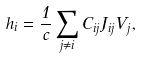Convert formula to latex. <formula><loc_0><loc_0><loc_500><loc_500>h _ { i } = \frac { 1 } { c } \sum _ { j \neq i } C _ { i j } J _ { i j } V _ { j } ,</formula> 